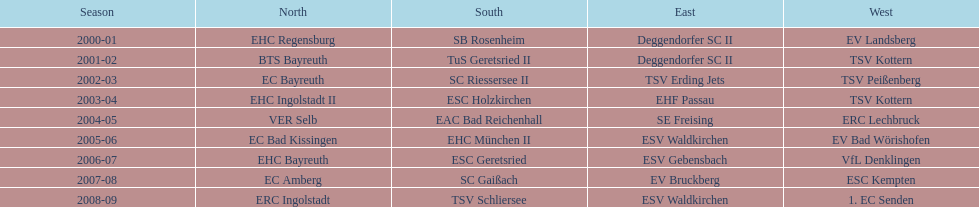Would you mind parsing the complete table? {'header': ['Season', 'North', 'South', 'East', 'West'], 'rows': [['2000-01', 'EHC Regensburg', 'SB Rosenheim', 'Deggendorfer SC II', 'EV Landsberg'], ['2001-02', 'BTS Bayreuth', 'TuS Geretsried II', 'Deggendorfer SC II', 'TSV Kottern'], ['2002-03', 'EC Bayreuth', 'SC Riessersee II', 'TSV Erding Jets', 'TSV Peißenberg'], ['2003-04', 'EHC Ingolstadt II', 'ESC Holzkirchen', 'EHF Passau', 'TSV Kottern'], ['2004-05', 'VER Selb', 'EAC Bad Reichenhall', 'SE Freising', 'ERC Lechbruck'], ['2005-06', 'EC Bad Kissingen', 'EHC München II', 'ESV Waldkirchen', 'EV Bad Wörishofen'], ['2006-07', 'EHC Bayreuth', 'ESC Geretsried', 'ESV Gebensbach', 'VfL Denklingen'], ['2007-08', 'EC Amberg', 'SC Gaißach', 'EV Bruckberg', 'ESC Kempten'], ['2008-09', 'ERC Ingolstadt', 'TSV Schliersee', 'ESV Waldkirchen', '1. EC Senden']]} Who emerged as the winner in the south after esc geretsried's performance in the 2006-07 season? SC Gaißach. 